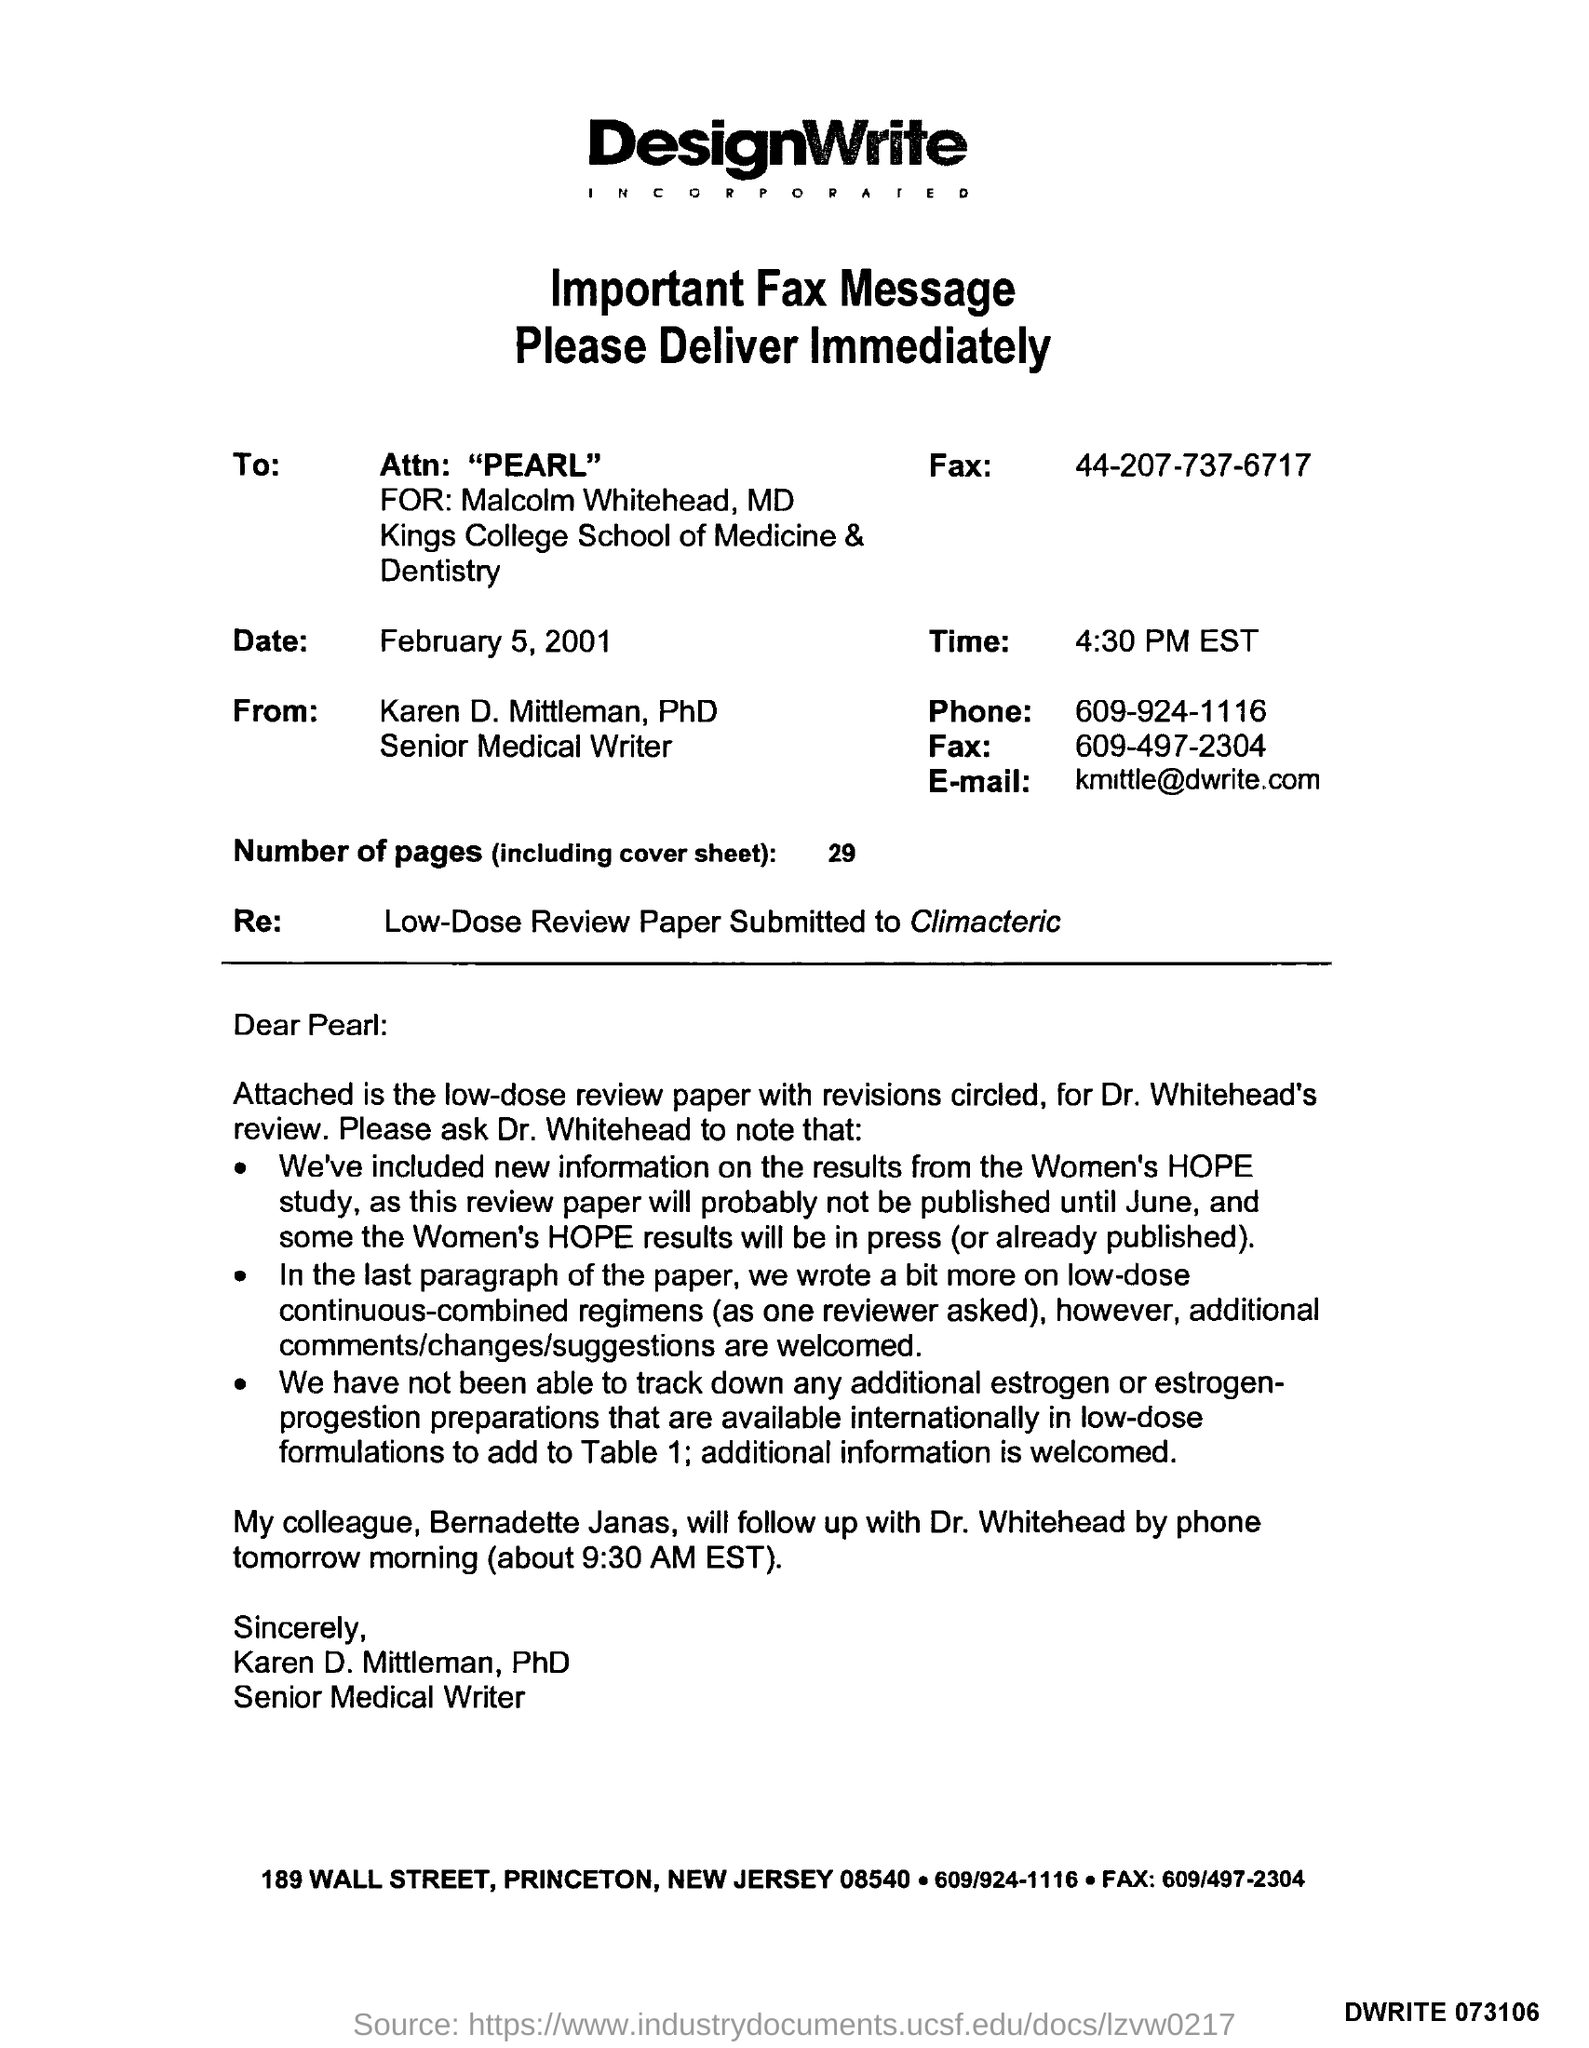Point out several critical features in this image. Attn" is mentioned in the context of PEARL, which stands for Problem, Effect, Additional Requirements, Legal Requirements, and Business Rules. 